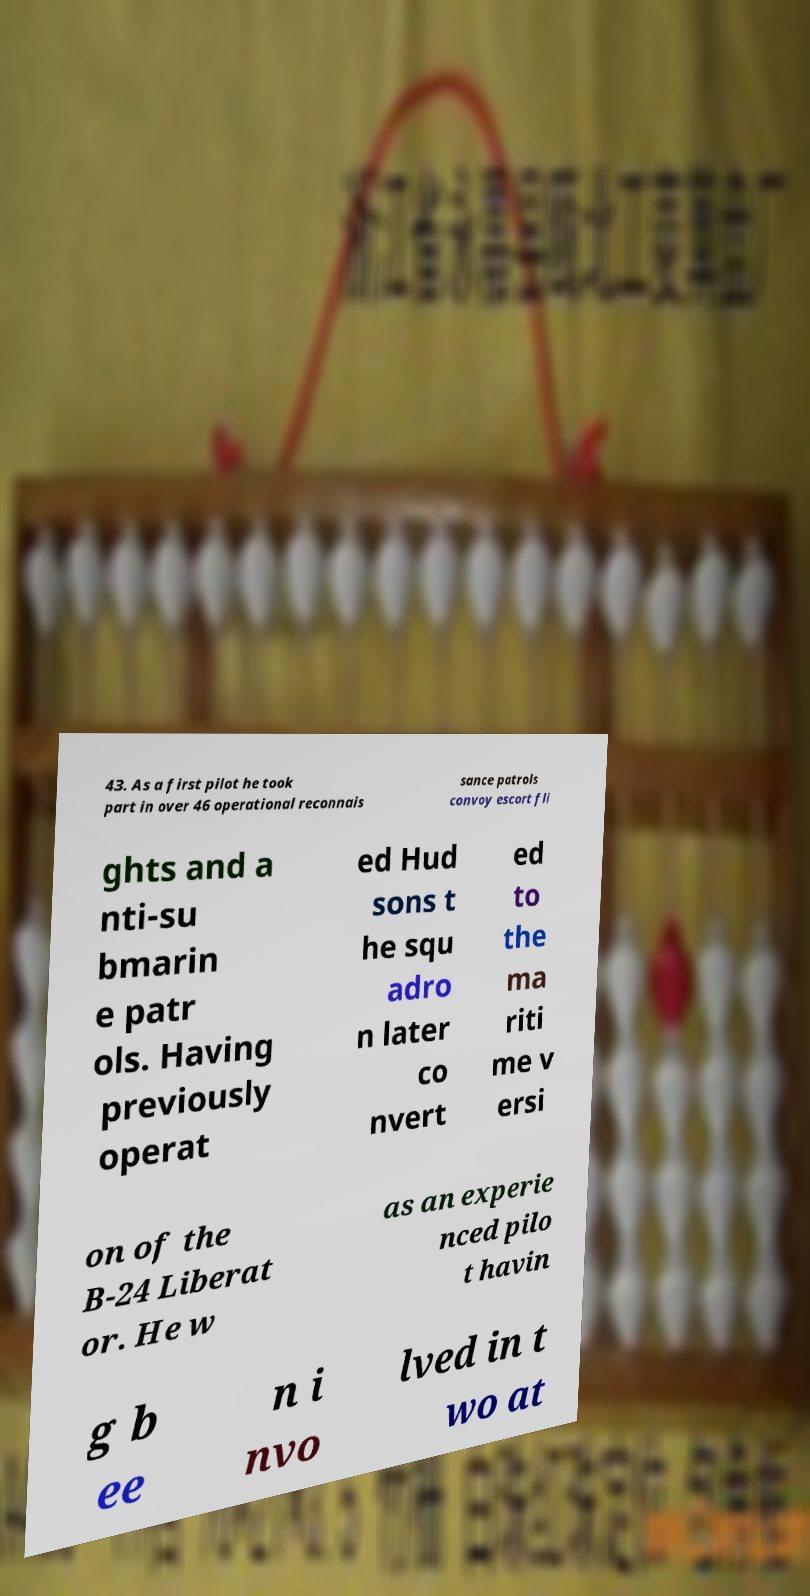For documentation purposes, I need the text within this image transcribed. Could you provide that? 43. As a first pilot he took part in over 46 operational reconnais sance patrols convoy escort fli ghts and a nti-su bmarin e patr ols. Having previously operat ed Hud sons t he squ adro n later co nvert ed to the ma riti me v ersi on of the B-24 Liberat or. He w as an experie nced pilo t havin g b ee n i nvo lved in t wo at 